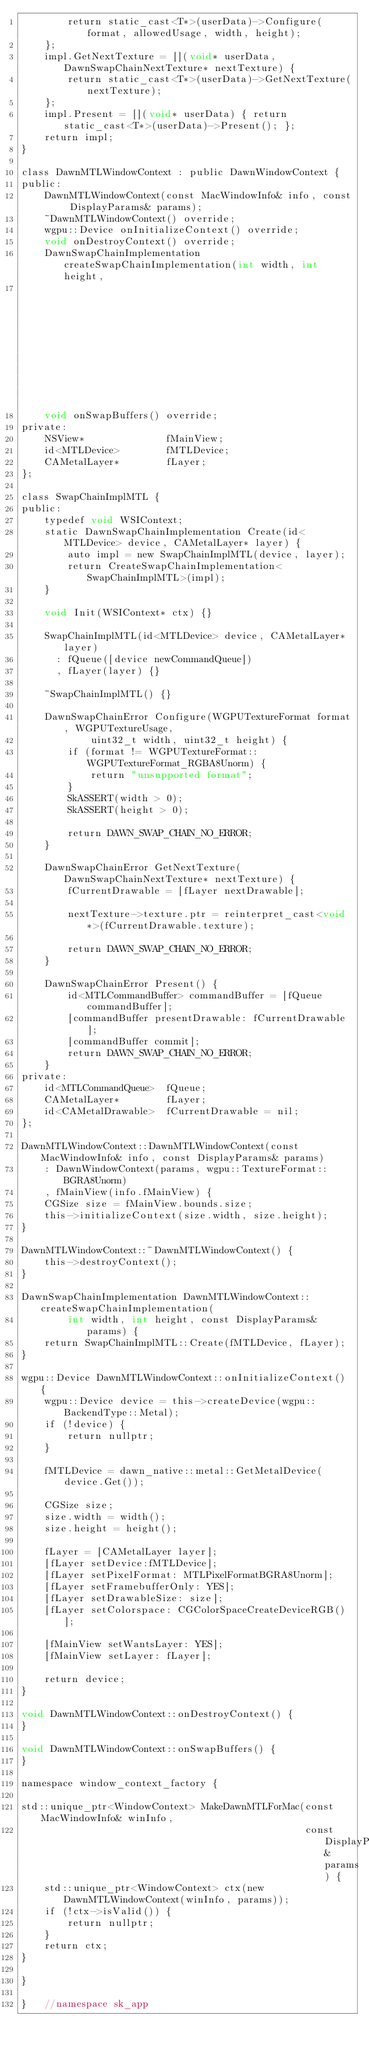Convert code to text. <code><loc_0><loc_0><loc_500><loc_500><_ObjectiveC_>        return static_cast<T*>(userData)->Configure(format, allowedUsage, width, height);
    };
    impl.GetNextTexture = [](void* userData, DawnSwapChainNextTexture* nextTexture) {
        return static_cast<T*>(userData)->GetNextTexture(nextTexture);
    };
    impl.Present = [](void* userData) { return static_cast<T*>(userData)->Present(); };
    return impl;
}

class DawnMTLWindowContext : public DawnWindowContext {
public:
    DawnMTLWindowContext(const MacWindowInfo& info, const DisplayParams& params);
    ~DawnMTLWindowContext() override;
    wgpu::Device onInitializeContext() override;
    void onDestroyContext() override;
    DawnSwapChainImplementation createSwapChainImplementation(int width, int height,
                                                              const DisplayParams& params) override;
    void onSwapBuffers() override;
private:
    NSView*              fMainView;
    id<MTLDevice>        fMTLDevice;
    CAMetalLayer*        fLayer;
};

class SwapChainImplMTL {
public:
    typedef void WSIContext;
    static DawnSwapChainImplementation Create(id<MTLDevice> device, CAMetalLayer* layer) {
        auto impl = new SwapChainImplMTL(device, layer);
        return CreateSwapChainImplementation<SwapChainImplMTL>(impl);
    }

    void Init(WSIContext* ctx) {}

    SwapChainImplMTL(id<MTLDevice> device, CAMetalLayer* layer)
      : fQueue([device newCommandQueue])
      , fLayer(layer) {}

    ~SwapChainImplMTL() {}

    DawnSwapChainError Configure(WGPUTextureFormat format, WGPUTextureUsage,
            uint32_t width, uint32_t height) {
        if (format != WGPUTextureFormat::WGPUTextureFormat_RGBA8Unorm) {
            return "unsupported format";
        }
        SkASSERT(width > 0);
        SkASSERT(height > 0);

        return DAWN_SWAP_CHAIN_NO_ERROR;
    }

    DawnSwapChainError GetNextTexture(DawnSwapChainNextTexture* nextTexture) {
        fCurrentDrawable = [fLayer nextDrawable];

        nextTexture->texture.ptr = reinterpret_cast<void*>(fCurrentDrawable.texture);

        return DAWN_SWAP_CHAIN_NO_ERROR;
    }

    DawnSwapChainError Present() {
        id<MTLCommandBuffer> commandBuffer = [fQueue commandBuffer];
        [commandBuffer presentDrawable: fCurrentDrawable];
        [commandBuffer commit];
        return DAWN_SWAP_CHAIN_NO_ERROR;
    }
private:
    id<MTLCommandQueue>  fQueue;
    CAMetalLayer*        fLayer;
    id<CAMetalDrawable>  fCurrentDrawable = nil;
};

DawnMTLWindowContext::DawnMTLWindowContext(const MacWindowInfo& info, const DisplayParams& params)
    : DawnWindowContext(params, wgpu::TextureFormat::BGRA8Unorm)
    , fMainView(info.fMainView) {
    CGSize size = fMainView.bounds.size;
    this->initializeContext(size.width, size.height);
}

DawnMTLWindowContext::~DawnMTLWindowContext() {
    this->destroyContext();
}

DawnSwapChainImplementation DawnMTLWindowContext::createSwapChainImplementation(
        int width, int height, const DisplayParams& params) {
    return SwapChainImplMTL::Create(fMTLDevice, fLayer);
}

wgpu::Device DawnMTLWindowContext::onInitializeContext() {
    wgpu::Device device = this->createDevice(wgpu::BackendType::Metal);
    if (!device) {
        return nullptr;
    }

    fMTLDevice = dawn_native::metal::GetMetalDevice(device.Get());

    CGSize size;
    size.width = width();
    size.height = height();

    fLayer = [CAMetalLayer layer];
    [fLayer setDevice:fMTLDevice];
    [fLayer setPixelFormat: MTLPixelFormatBGRA8Unorm];
    [fLayer setFramebufferOnly: YES];
    [fLayer setDrawableSize: size];
    [fLayer setColorspace: CGColorSpaceCreateDeviceRGB()];

    [fMainView setWantsLayer: YES];
    [fMainView setLayer: fLayer];

    return device;
}

void DawnMTLWindowContext::onDestroyContext() {
}

void DawnMTLWindowContext::onSwapBuffers() {
}

namespace window_context_factory {

std::unique_ptr<WindowContext> MakeDawnMTLForMac(const MacWindowInfo& winInfo,
                                                 const DisplayParams& params) {
    std::unique_ptr<WindowContext> ctx(new DawnMTLWindowContext(winInfo, params));
    if (!ctx->isValid()) {
        return nullptr;
    }
    return ctx;
}

}

}   //namespace sk_app
</code> 